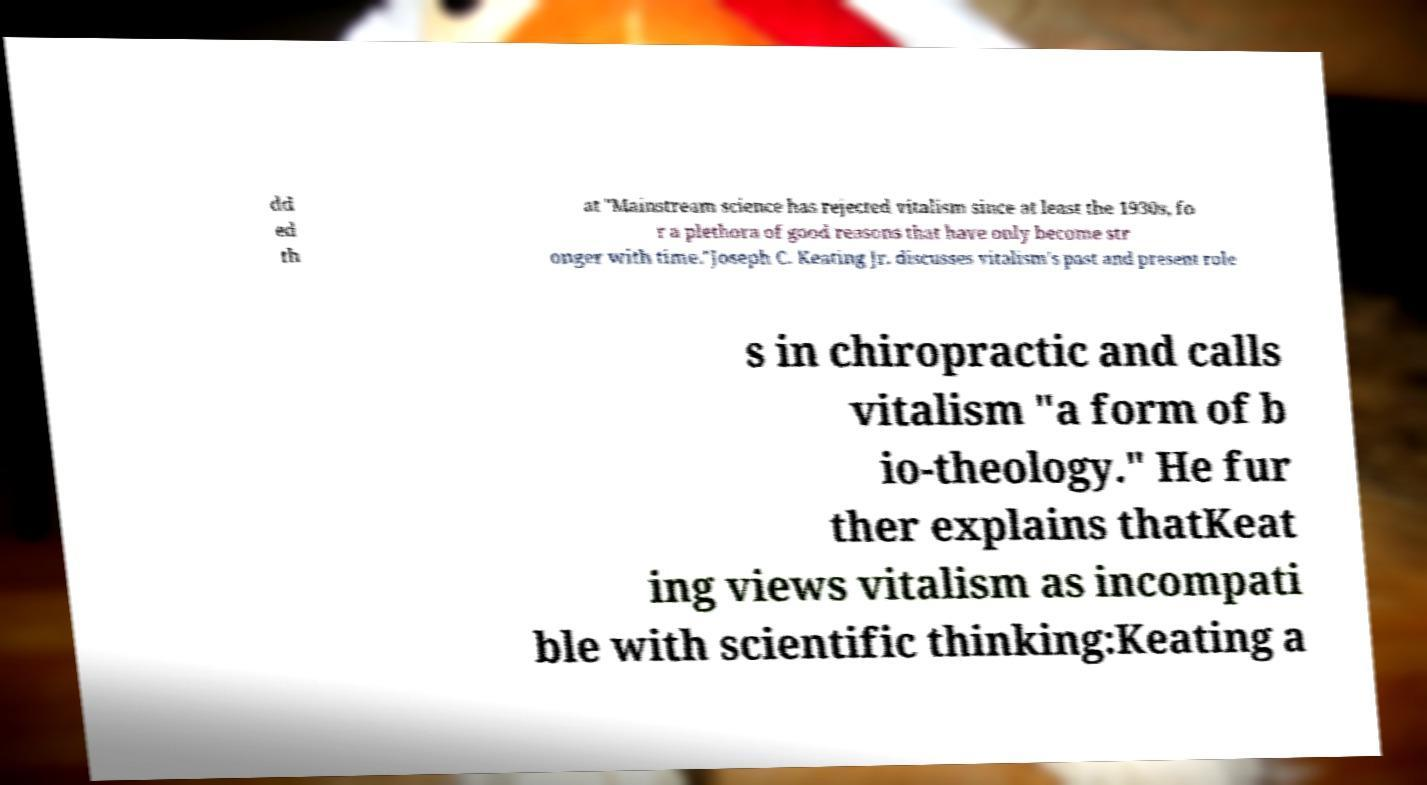I need the written content from this picture converted into text. Can you do that? dd ed th at "Mainstream science has rejected vitalism since at least the 1930s, fo r a plethora of good reasons that have only become str onger with time."Joseph C. Keating Jr. discusses vitalism's past and present role s in chiropractic and calls vitalism "a form of b io-theology." He fur ther explains thatKeat ing views vitalism as incompati ble with scientific thinking:Keating a 